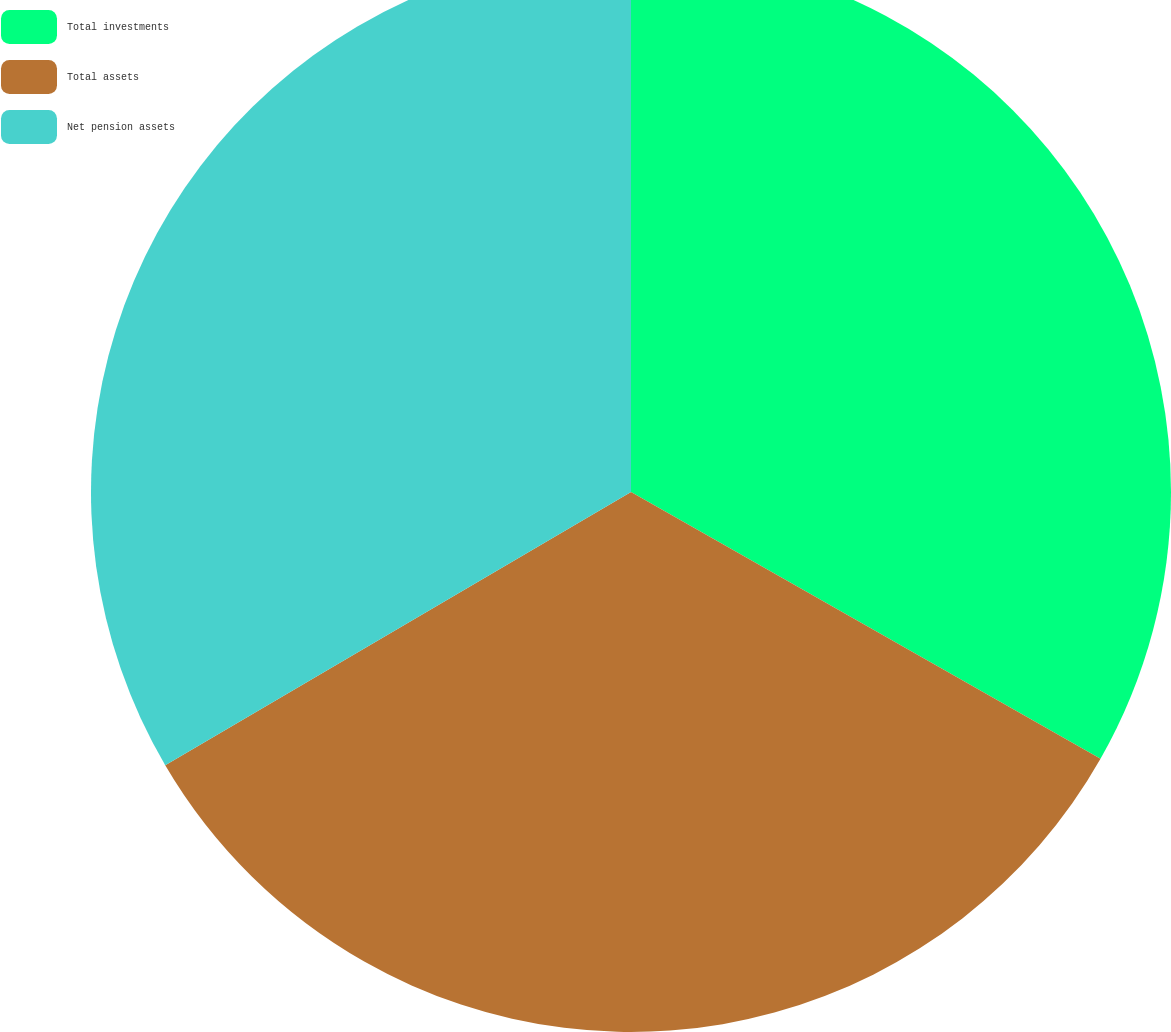<chart> <loc_0><loc_0><loc_500><loc_500><pie_chart><fcel>Total investments<fcel>Total assets<fcel>Net pension assets<nl><fcel>33.22%<fcel>33.33%<fcel>33.44%<nl></chart> 